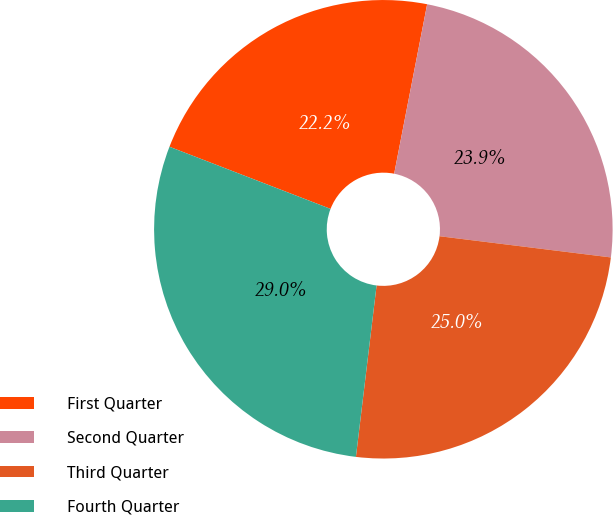Convert chart to OTSL. <chart><loc_0><loc_0><loc_500><loc_500><pie_chart><fcel>First Quarter<fcel>Second Quarter<fcel>Third Quarter<fcel>Fourth Quarter<nl><fcel>22.2%<fcel>23.9%<fcel>24.95%<fcel>28.95%<nl></chart> 